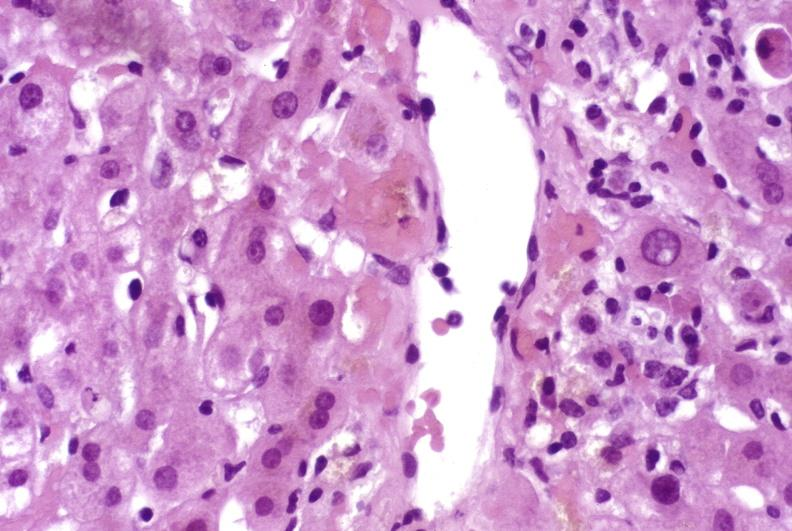what is present?
Answer the question using a single word or phrase. Hepatobiliary 